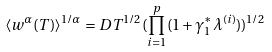Convert formula to latex. <formula><loc_0><loc_0><loc_500><loc_500>\langle w ^ { \alpha } ( T ) \rangle ^ { 1 / \alpha } = D T ^ { 1 / 2 } ( \prod _ { i = 1 } ^ { p } ( 1 + \gamma _ { 1 } ^ { \ast } \lambda ^ { ( i ) } ) ) ^ { 1 / 2 }</formula> 